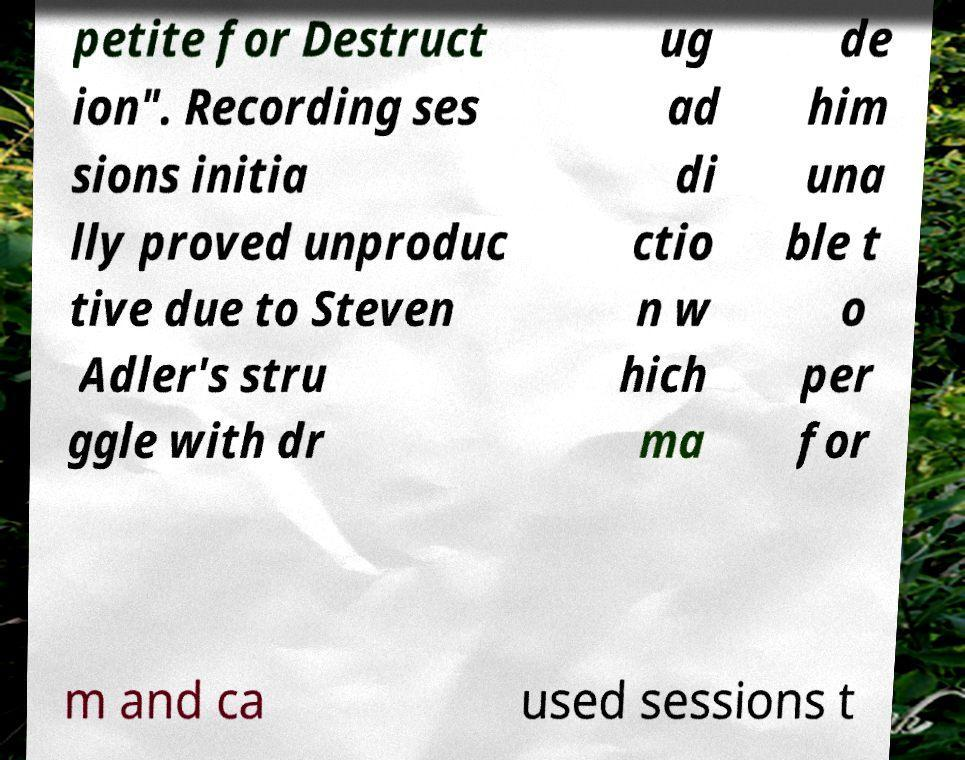For documentation purposes, I need the text within this image transcribed. Could you provide that? petite for Destruct ion". Recording ses sions initia lly proved unproduc tive due to Steven Adler's stru ggle with dr ug ad di ctio n w hich ma de him una ble t o per for m and ca used sessions t 